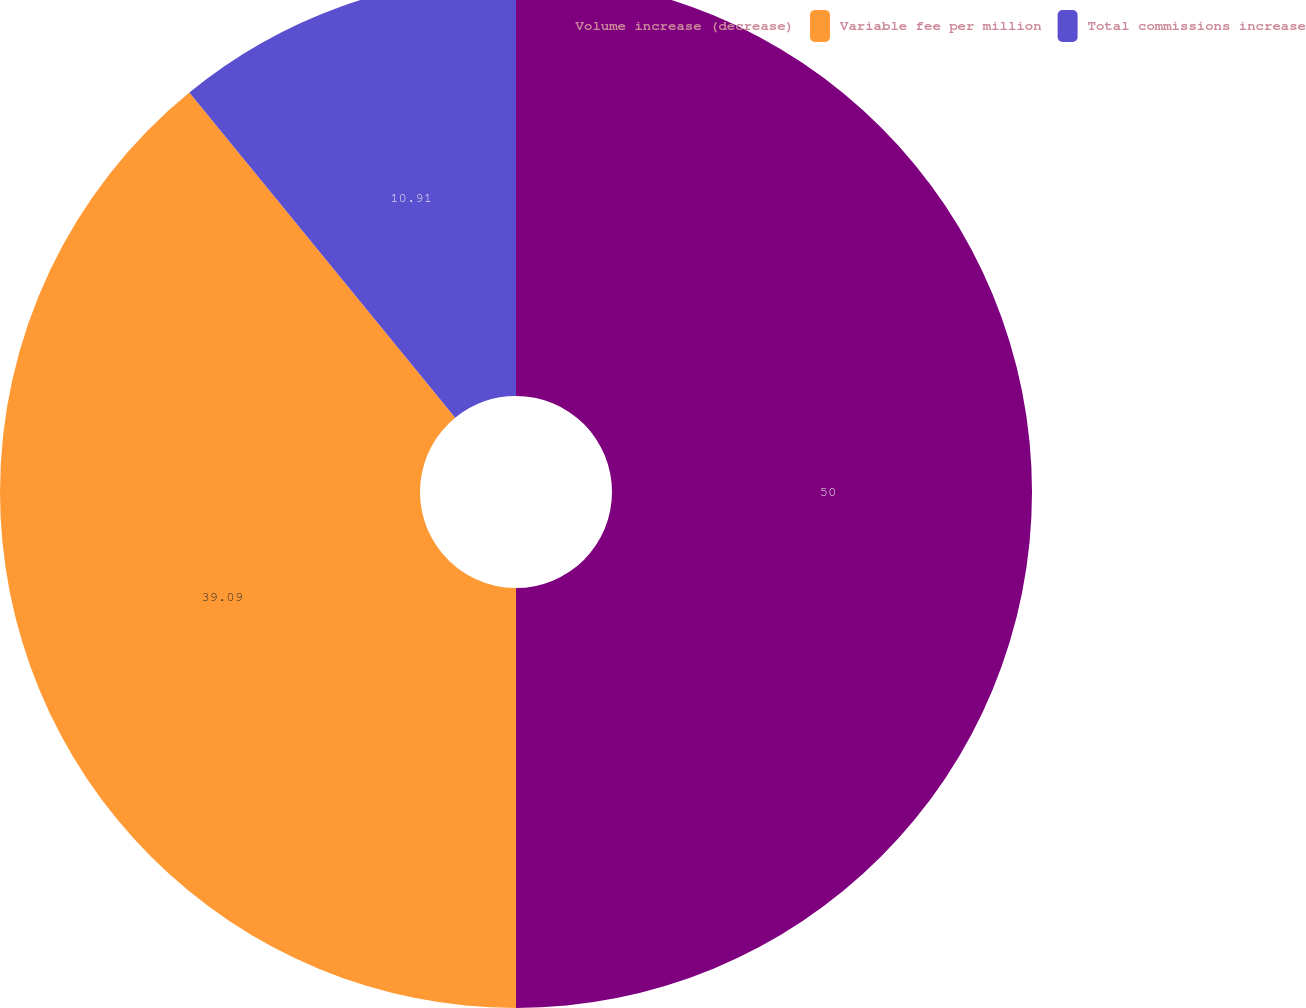Convert chart to OTSL. <chart><loc_0><loc_0><loc_500><loc_500><pie_chart><fcel>Volume increase (decrease)<fcel>Variable fee per million<fcel>Total commissions increase<nl><fcel>50.0%<fcel>39.09%<fcel>10.91%<nl></chart> 